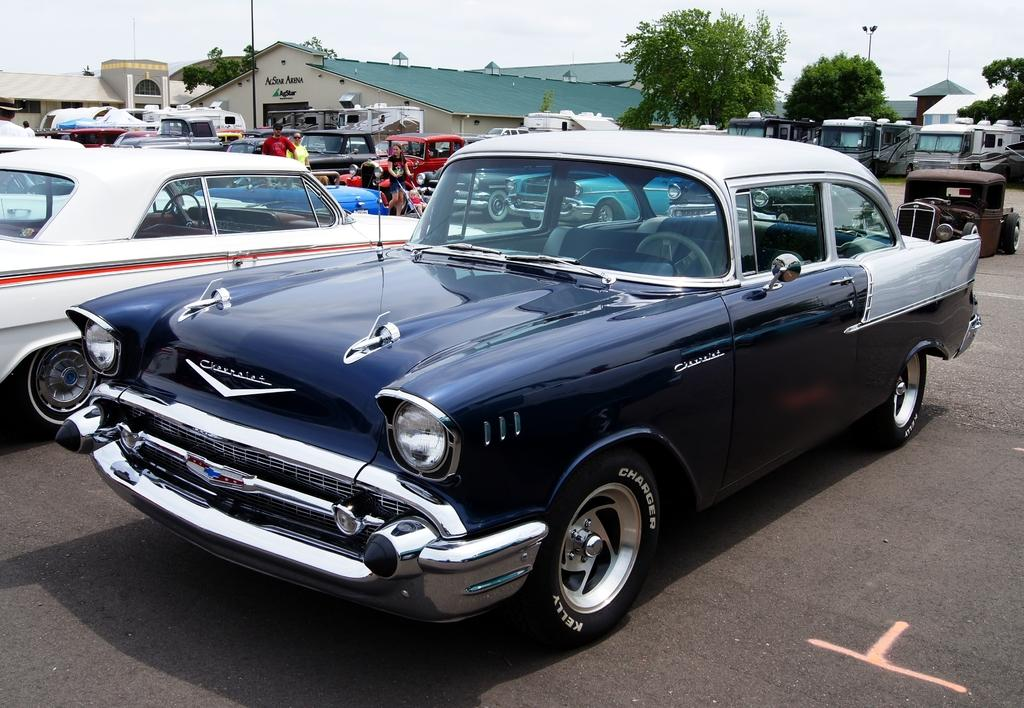What can be seen in the image? There are vehicles and persons on the ground in the image. What is visible in the background of the image? There are sheds, trees, and the sky visible in the background of the image. Can you see any notes being passed between the persons in the image? There is no mention of notes or any communication between the persons in the image. --- 